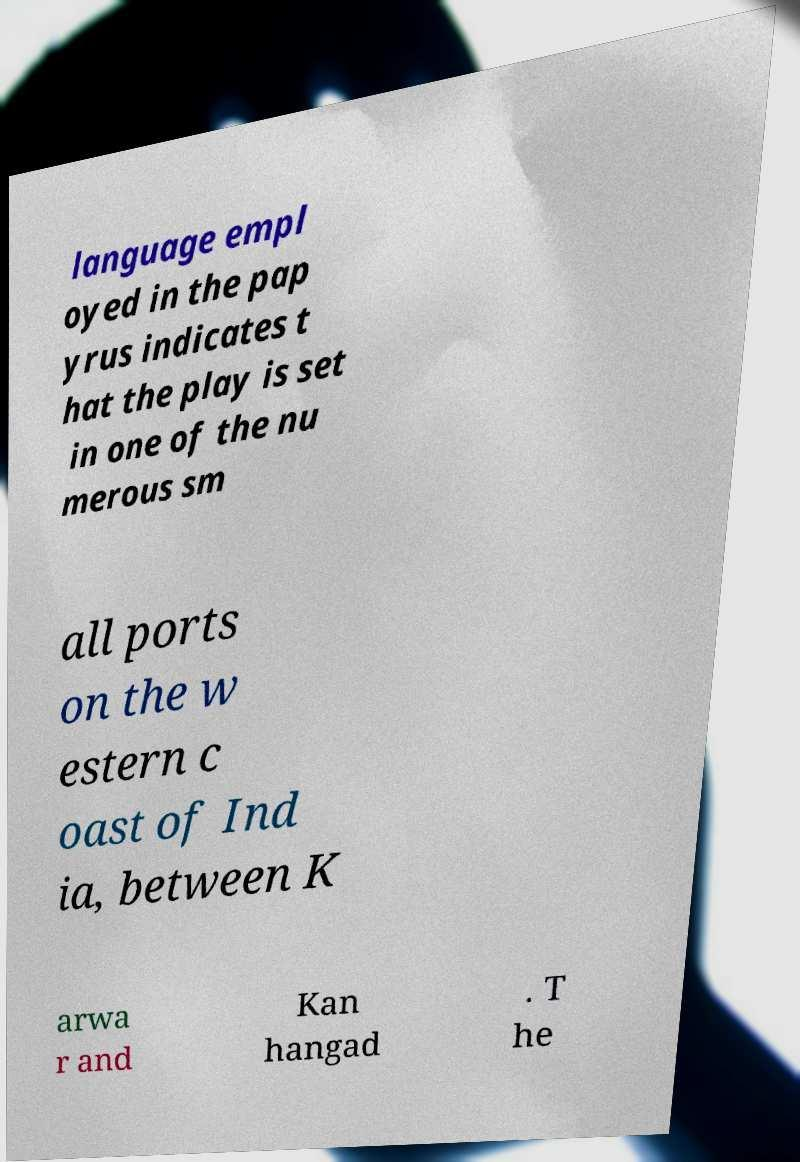What messages or text are displayed in this image? I need them in a readable, typed format. language empl oyed in the pap yrus indicates t hat the play is set in one of the nu merous sm all ports on the w estern c oast of Ind ia, between K arwa r and Kan hangad . T he 